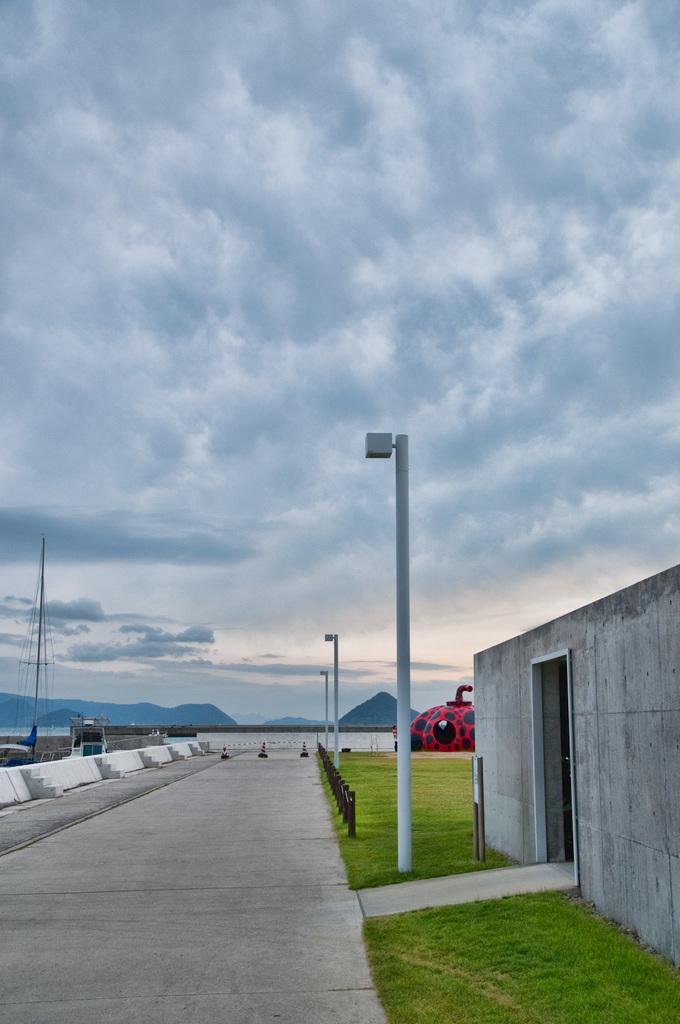Can you describe this image briefly? In this image I can see few poles, few wires, grass, a red colour thing over there and in the clouds and the sky. 